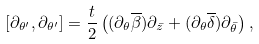<formula> <loc_0><loc_0><loc_500><loc_500>[ \partial _ { \theta ^ { \prime } } , \partial _ { \theta ^ { \prime } } ] = \frac { t } { 2 } \left ( ( \partial _ { \theta } \overline { \beta } ) \partial _ { \bar { z } } + ( \partial _ { \theta } \overline { \delta } ) \partial _ { \bar { \theta } } \right ) ,</formula> 